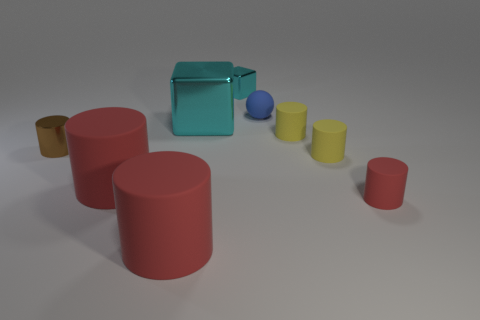There is a tiny object that is both to the left of the blue matte thing and in front of the tiny cyan cube; what color is it?
Your answer should be compact. Brown. There is a tiny metal object in front of the small cyan object; are there any small red rubber things that are on the left side of it?
Ensure brevity in your answer.  No. Are there an equal number of tiny spheres in front of the blue rubber sphere and red rubber things?
Your answer should be very brief. No. How many things are behind the small thing that is to the left of the red cylinder in front of the tiny red object?
Your response must be concise. 4. Is there a brown rubber sphere that has the same size as the blue sphere?
Keep it short and to the point. No. Is the number of shiny objects behind the small rubber sphere less than the number of small metallic cubes?
Give a very brief answer. No. What material is the cyan thing that is on the right side of the cyan metal thing in front of the cyan metallic object behind the blue rubber sphere?
Provide a short and direct response. Metal. Is the number of red objects that are on the left side of the tiny sphere greater than the number of tiny balls that are to the left of the tiny metallic block?
Ensure brevity in your answer.  Yes. What number of shiny objects are small spheres or red cylinders?
Your answer should be compact. 0. The small thing that is the same color as the big cube is what shape?
Provide a succinct answer. Cube. 